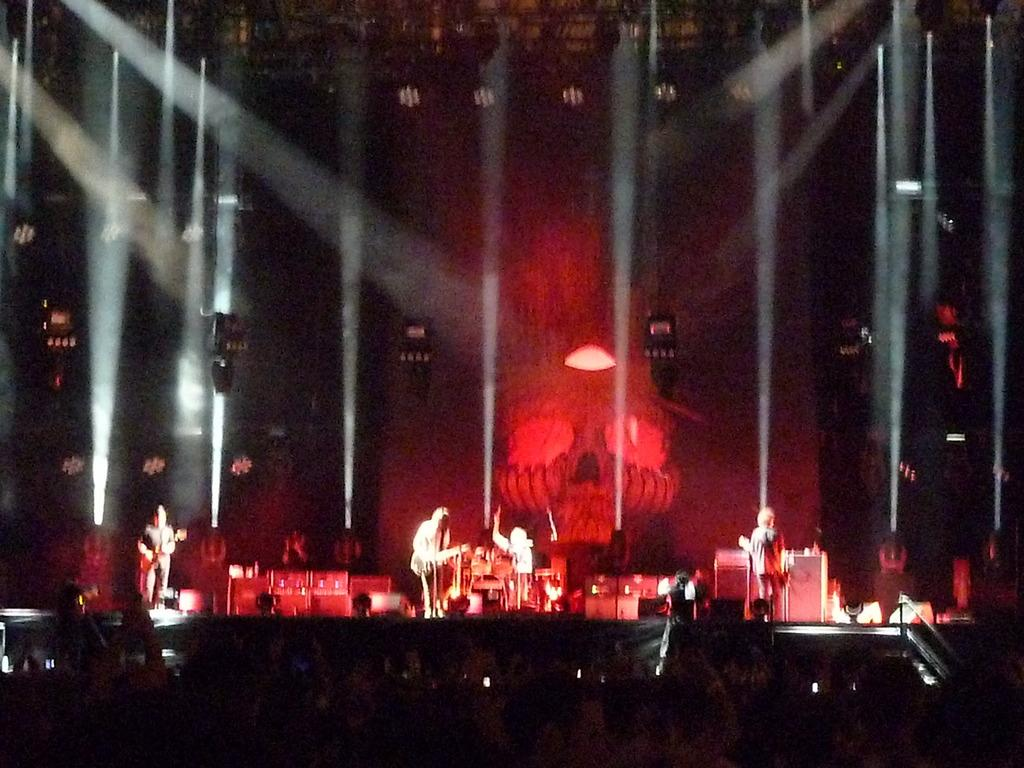What type of event is taking place in the image? It is a musical concert. What can be seen on stage during the event? There are people holding musical instruments on stage. Can you describe the lighting conditions in the image? The image is taken in a dark environment. How clear is the image? The image is blurry. Can you tell me how many oranges are being used as percussion instruments in the image? There are no oranges present in the image, and they are not being used as percussion instruments. What type of donkey can be seen performing on stage in the image? There is no donkey present in the image, and no animals are performing on stage. 